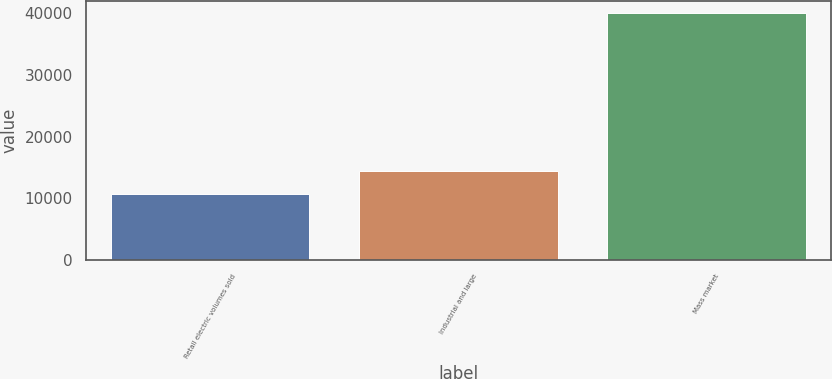<chart> <loc_0><loc_0><loc_500><loc_500><bar_chart><fcel>Retail electric volumes sold<fcel>Industrial and large<fcel>Mass market<nl><fcel>10749<fcel>14491<fcel>39976<nl></chart> 